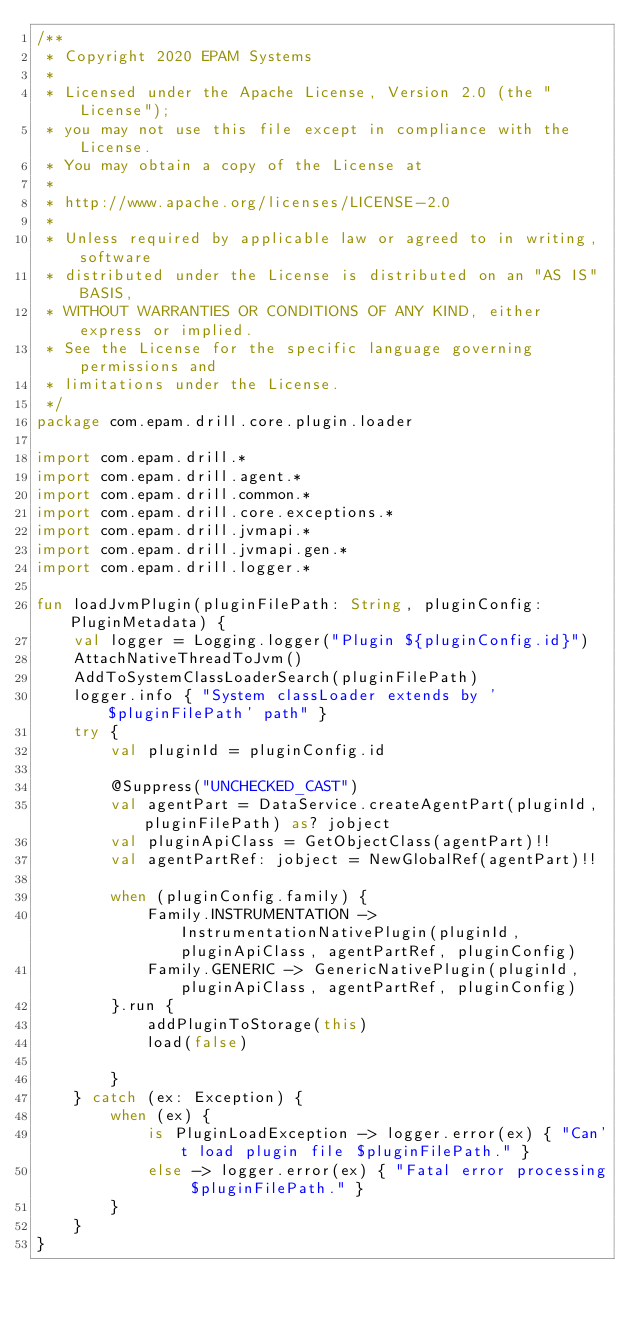Convert code to text. <code><loc_0><loc_0><loc_500><loc_500><_Kotlin_>/**
 * Copyright 2020 EPAM Systems
 *
 * Licensed under the Apache License, Version 2.0 (the "License");
 * you may not use this file except in compliance with the License.
 * You may obtain a copy of the License at
 *
 * http://www.apache.org/licenses/LICENSE-2.0
 *
 * Unless required by applicable law or agreed to in writing, software
 * distributed under the License is distributed on an "AS IS" BASIS,
 * WITHOUT WARRANTIES OR CONDITIONS OF ANY KIND, either express or implied.
 * See the License for the specific language governing permissions and
 * limitations under the License.
 */
package com.epam.drill.core.plugin.loader

import com.epam.drill.*
import com.epam.drill.agent.*
import com.epam.drill.common.*
import com.epam.drill.core.exceptions.*
import com.epam.drill.jvmapi.*
import com.epam.drill.jvmapi.gen.*
import com.epam.drill.logger.*

fun loadJvmPlugin(pluginFilePath: String, pluginConfig: PluginMetadata) {
    val logger = Logging.logger("Plugin ${pluginConfig.id}")
    AttachNativeThreadToJvm()
    AddToSystemClassLoaderSearch(pluginFilePath)
    logger.info { "System classLoader extends by '$pluginFilePath' path" }
    try {
        val pluginId = pluginConfig.id

        @Suppress("UNCHECKED_CAST")
        val agentPart = DataService.createAgentPart(pluginId, pluginFilePath) as? jobject
        val pluginApiClass = GetObjectClass(agentPart)!!
        val agentPartRef: jobject = NewGlobalRef(agentPart)!!

        when (pluginConfig.family) {
            Family.INSTRUMENTATION -> InstrumentationNativePlugin(pluginId, pluginApiClass, agentPartRef, pluginConfig)
            Family.GENERIC -> GenericNativePlugin(pluginId, pluginApiClass, agentPartRef, pluginConfig)
        }.run {
            addPluginToStorage(this)
            load(false)

        }
    } catch (ex: Exception) {
        when (ex) {
            is PluginLoadException -> logger.error(ex) { "Can't load plugin file $pluginFilePath." }
            else -> logger.error(ex) { "Fatal error processing $pluginFilePath." }
        }
    }
}
</code> 